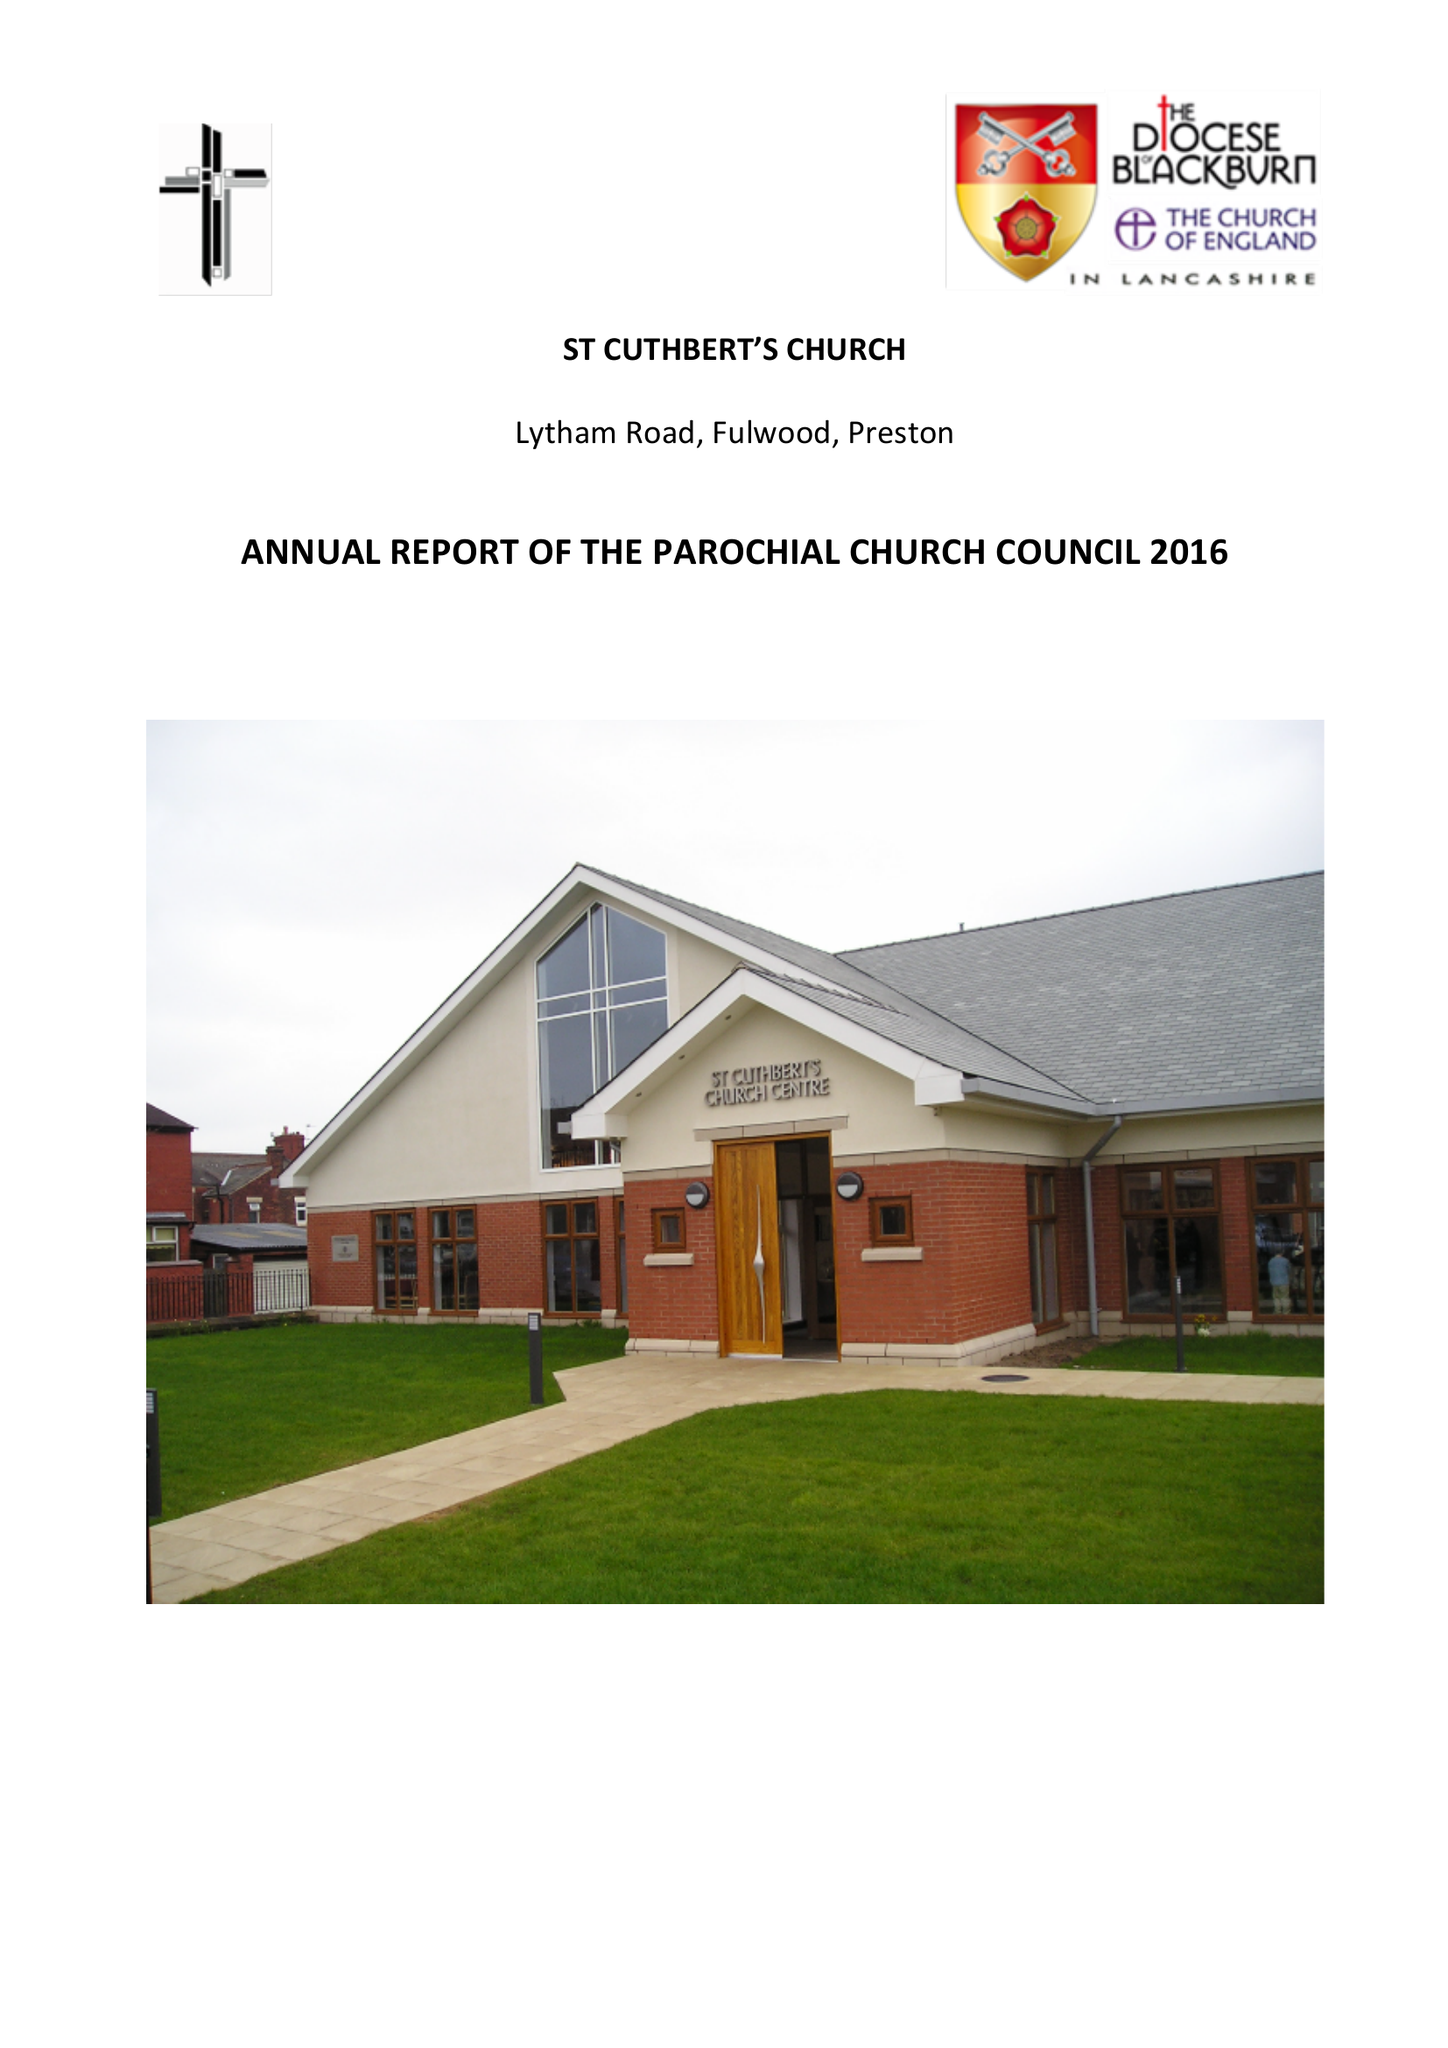What is the value for the address__street_line?
Answer the question using a single word or phrase. LYTHAM ROAD 